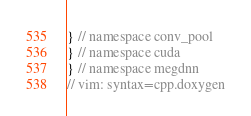Convert code to text. <code><loc_0><loc_0><loc_500><loc_500><_Cuda_>} // namespace conv_pool
} // namespace cuda
} // namespace megdnn
// vim: syntax=cpp.doxygen
</code> 